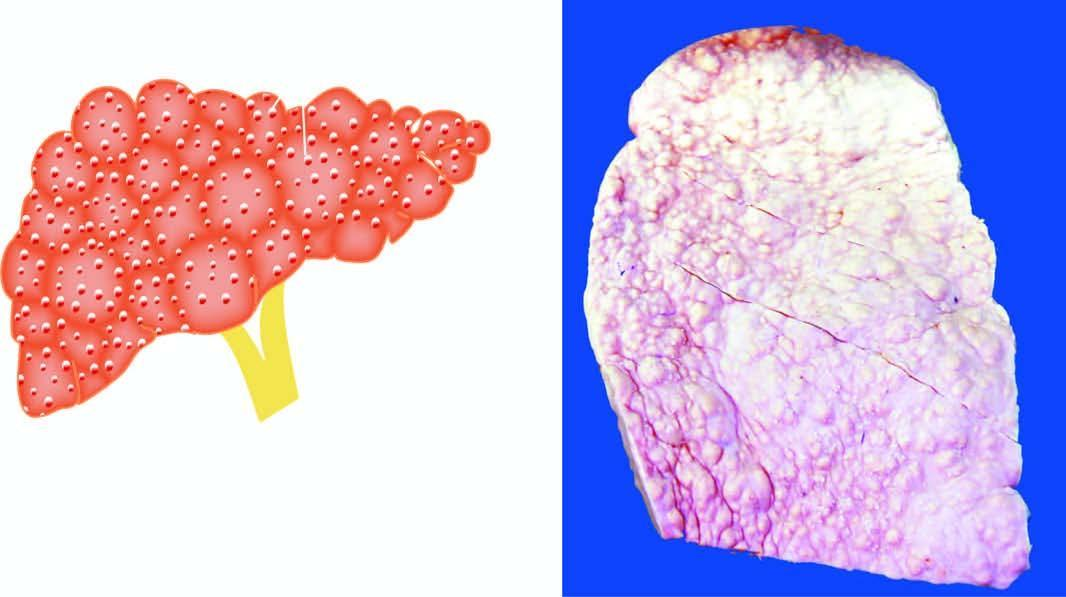what is small, distorted and irregularly scarred?
Answer the question using a single word or phrase. Liver 